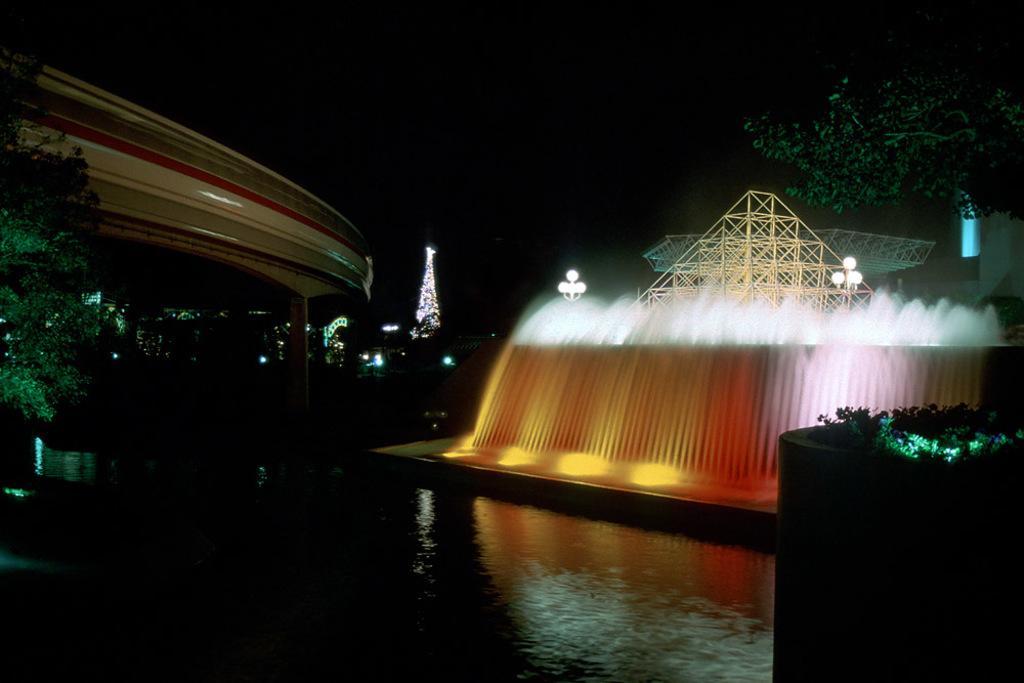Could you give a brief overview of what you see in this image? In the picture I can see the decorative lighting waterfall on the right side. I can see the metal scaffolding structures. There is a tree on the left side and the right side. I can see the water at the bottom of the picture. It is looking like a building on the top left side of the picture. 